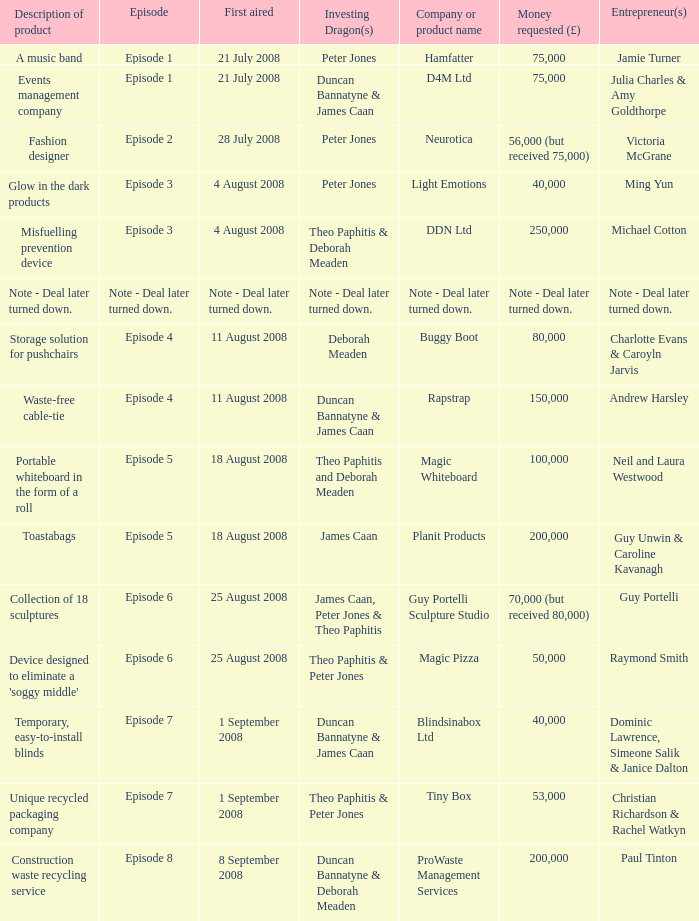When did episode 6 first air with entrepreneur Guy Portelli? 25 August 2008. 